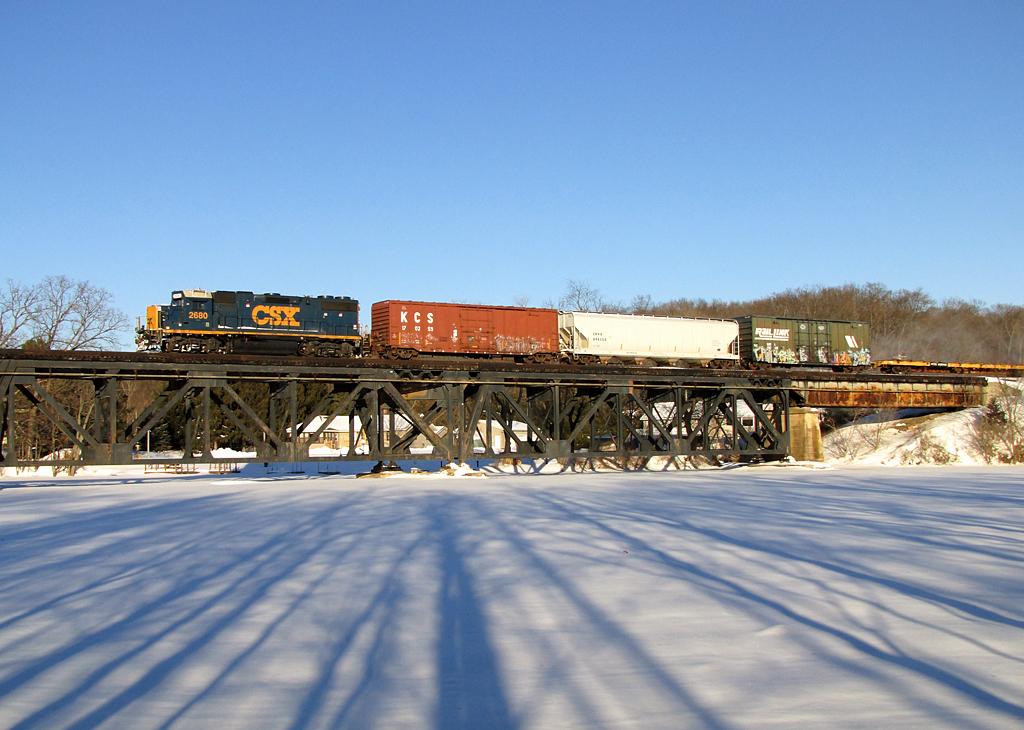What color is the text on the dark-blue background?
Provide a succinct answer. Orange. Which company does the cart 2680 belong to?
Provide a succinct answer. Csx. 